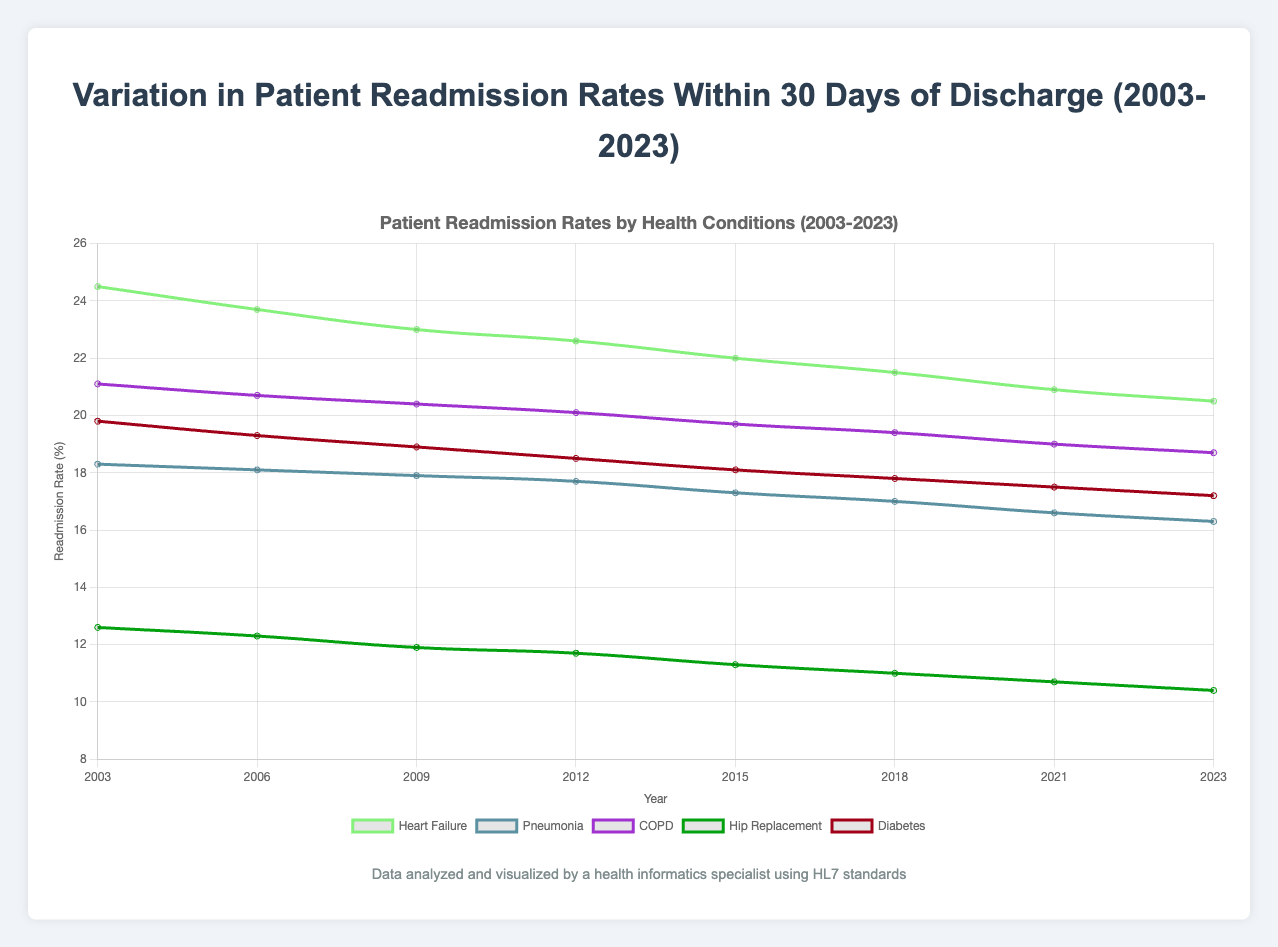Which health condition had the highest readmission rate in 2003? To find the highest readmission rate for 2003, I identified the values for each condition. Heart Failure had a readmission rate of 24.5%, which was the highest among the listed conditions.
Answer: Heart Failure How did the readmission rate for Hip Replacement change from 2003 to 2023? By looking at the data points for Hip Replacement, the readmission rate decreased from 12.6% in 2003 to 10.4% in 2023. This is a reduction of 2.2%.
Answer: Decreased by 2.2% What is the average readmission rate for Diabetes over the recorded years? To find the average, I summed the readmission rates for Diabetes across all years and divided by the number of years: (19.8 + 19.3 + 18.9 + 18.5 + 18.1 + 17.8 + 17.5 + 17.2) / 8 = 18.39%.
Answer: 18.39% What is the trend in Pneumonia readmission rates over the years? By observing the readmission rates for Pneumonia from 2003 to 2023: 18.3%, 18.1%, 17.9%, 17.7%, 17.3%, 17.0%, 16.6%, 16.3%, there is a consistent decrease in readmission rates.
Answer: Consistent decrease What's the range of readmission rates for COPD in 2021? Considering a single year, we only have one data point for COPD readmission rate in 2021, which is 19.0%. Therefore, the range for a single data point is 0.
Answer: 0 